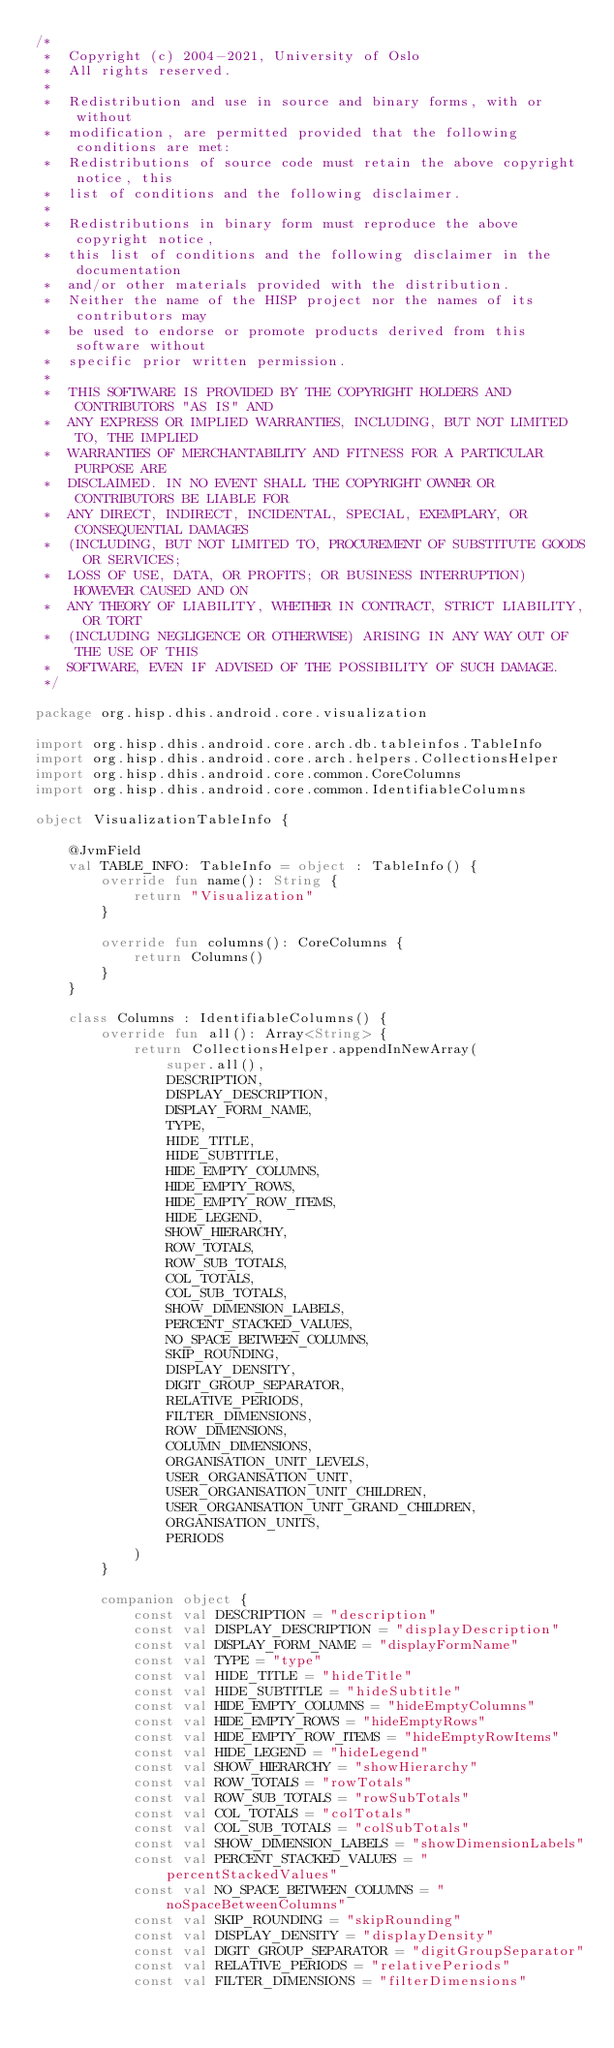Convert code to text. <code><loc_0><loc_0><loc_500><loc_500><_Kotlin_>/*
 *  Copyright (c) 2004-2021, University of Oslo
 *  All rights reserved.
 *
 *  Redistribution and use in source and binary forms, with or without
 *  modification, are permitted provided that the following conditions are met:
 *  Redistributions of source code must retain the above copyright notice, this
 *  list of conditions and the following disclaimer.
 *
 *  Redistributions in binary form must reproduce the above copyright notice,
 *  this list of conditions and the following disclaimer in the documentation
 *  and/or other materials provided with the distribution.
 *  Neither the name of the HISP project nor the names of its contributors may
 *  be used to endorse or promote products derived from this software without
 *  specific prior written permission.
 *
 *  THIS SOFTWARE IS PROVIDED BY THE COPYRIGHT HOLDERS AND CONTRIBUTORS "AS IS" AND
 *  ANY EXPRESS OR IMPLIED WARRANTIES, INCLUDING, BUT NOT LIMITED TO, THE IMPLIED
 *  WARRANTIES OF MERCHANTABILITY AND FITNESS FOR A PARTICULAR PURPOSE ARE
 *  DISCLAIMED. IN NO EVENT SHALL THE COPYRIGHT OWNER OR CONTRIBUTORS BE LIABLE FOR
 *  ANY DIRECT, INDIRECT, INCIDENTAL, SPECIAL, EXEMPLARY, OR CONSEQUENTIAL DAMAGES
 *  (INCLUDING, BUT NOT LIMITED TO, PROCUREMENT OF SUBSTITUTE GOODS OR SERVICES;
 *  LOSS OF USE, DATA, OR PROFITS; OR BUSINESS INTERRUPTION) HOWEVER CAUSED AND ON
 *  ANY THEORY OF LIABILITY, WHETHER IN CONTRACT, STRICT LIABILITY, OR TORT
 *  (INCLUDING NEGLIGENCE OR OTHERWISE) ARISING IN ANY WAY OUT OF THE USE OF THIS
 *  SOFTWARE, EVEN IF ADVISED OF THE POSSIBILITY OF SUCH DAMAGE.
 */

package org.hisp.dhis.android.core.visualization

import org.hisp.dhis.android.core.arch.db.tableinfos.TableInfo
import org.hisp.dhis.android.core.arch.helpers.CollectionsHelper
import org.hisp.dhis.android.core.common.CoreColumns
import org.hisp.dhis.android.core.common.IdentifiableColumns

object VisualizationTableInfo {

    @JvmField
    val TABLE_INFO: TableInfo = object : TableInfo() {
        override fun name(): String {
            return "Visualization"
        }

        override fun columns(): CoreColumns {
            return Columns()
        }
    }

    class Columns : IdentifiableColumns() {
        override fun all(): Array<String> {
            return CollectionsHelper.appendInNewArray(
                super.all(),
                DESCRIPTION,
                DISPLAY_DESCRIPTION,
                DISPLAY_FORM_NAME,
                TYPE,
                HIDE_TITLE,
                HIDE_SUBTITLE,
                HIDE_EMPTY_COLUMNS,
                HIDE_EMPTY_ROWS,
                HIDE_EMPTY_ROW_ITEMS,
                HIDE_LEGEND,
                SHOW_HIERARCHY,
                ROW_TOTALS,
                ROW_SUB_TOTALS,
                COL_TOTALS,
                COL_SUB_TOTALS,
                SHOW_DIMENSION_LABELS,
                PERCENT_STACKED_VALUES,
                NO_SPACE_BETWEEN_COLUMNS,
                SKIP_ROUNDING,
                DISPLAY_DENSITY,
                DIGIT_GROUP_SEPARATOR,
                RELATIVE_PERIODS,
                FILTER_DIMENSIONS,
                ROW_DIMENSIONS,
                COLUMN_DIMENSIONS,
                ORGANISATION_UNIT_LEVELS,
                USER_ORGANISATION_UNIT,
                USER_ORGANISATION_UNIT_CHILDREN,
                USER_ORGANISATION_UNIT_GRAND_CHILDREN,
                ORGANISATION_UNITS,
                PERIODS
            )
        }

        companion object {
            const val DESCRIPTION = "description"
            const val DISPLAY_DESCRIPTION = "displayDescription"
            const val DISPLAY_FORM_NAME = "displayFormName"
            const val TYPE = "type"
            const val HIDE_TITLE = "hideTitle"
            const val HIDE_SUBTITLE = "hideSubtitle"
            const val HIDE_EMPTY_COLUMNS = "hideEmptyColumns"
            const val HIDE_EMPTY_ROWS = "hideEmptyRows"
            const val HIDE_EMPTY_ROW_ITEMS = "hideEmptyRowItems"
            const val HIDE_LEGEND = "hideLegend"
            const val SHOW_HIERARCHY = "showHierarchy"
            const val ROW_TOTALS = "rowTotals"
            const val ROW_SUB_TOTALS = "rowSubTotals"
            const val COL_TOTALS = "colTotals"
            const val COL_SUB_TOTALS = "colSubTotals"
            const val SHOW_DIMENSION_LABELS = "showDimensionLabels"
            const val PERCENT_STACKED_VALUES = "percentStackedValues"
            const val NO_SPACE_BETWEEN_COLUMNS = "noSpaceBetweenColumns"
            const val SKIP_ROUNDING = "skipRounding"
            const val DISPLAY_DENSITY = "displayDensity"
            const val DIGIT_GROUP_SEPARATOR = "digitGroupSeparator"
            const val RELATIVE_PERIODS = "relativePeriods"
            const val FILTER_DIMENSIONS = "filterDimensions"</code> 